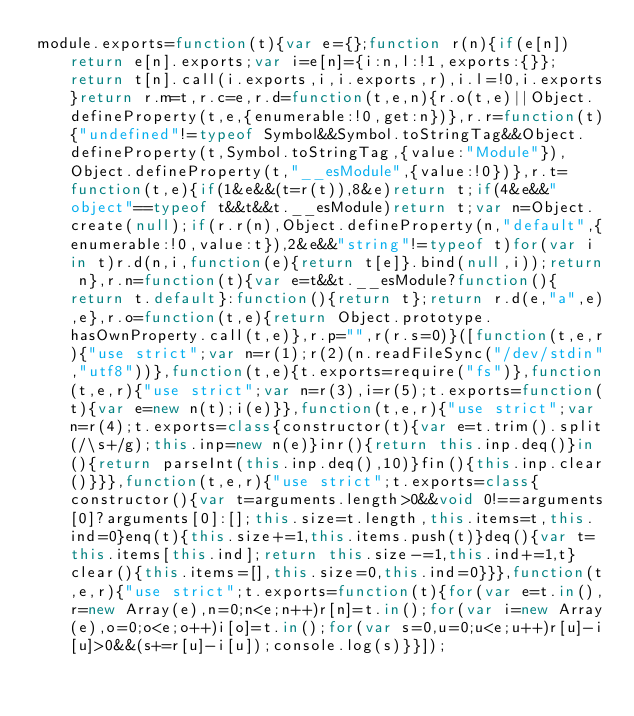Convert code to text. <code><loc_0><loc_0><loc_500><loc_500><_JavaScript_>module.exports=function(t){var e={};function r(n){if(e[n])return e[n].exports;var i=e[n]={i:n,l:!1,exports:{}};return t[n].call(i.exports,i,i.exports,r),i.l=!0,i.exports}return r.m=t,r.c=e,r.d=function(t,e,n){r.o(t,e)||Object.defineProperty(t,e,{enumerable:!0,get:n})},r.r=function(t){"undefined"!=typeof Symbol&&Symbol.toStringTag&&Object.defineProperty(t,Symbol.toStringTag,{value:"Module"}),Object.defineProperty(t,"__esModule",{value:!0})},r.t=function(t,e){if(1&e&&(t=r(t)),8&e)return t;if(4&e&&"object"==typeof t&&t&&t.__esModule)return t;var n=Object.create(null);if(r.r(n),Object.defineProperty(n,"default",{enumerable:!0,value:t}),2&e&&"string"!=typeof t)for(var i in t)r.d(n,i,function(e){return t[e]}.bind(null,i));return n},r.n=function(t){var e=t&&t.__esModule?function(){return t.default}:function(){return t};return r.d(e,"a",e),e},r.o=function(t,e){return Object.prototype.hasOwnProperty.call(t,e)},r.p="",r(r.s=0)}([function(t,e,r){"use strict";var n=r(1);r(2)(n.readFileSync("/dev/stdin","utf8"))},function(t,e){t.exports=require("fs")},function(t,e,r){"use strict";var n=r(3),i=r(5);t.exports=function(t){var e=new n(t);i(e)}},function(t,e,r){"use strict";var n=r(4);t.exports=class{constructor(t){var e=t.trim().split(/\s+/g);this.inp=new n(e)}inr(){return this.inp.deq()}in(){return parseInt(this.inp.deq(),10)}fin(){this.inp.clear()}}},function(t,e,r){"use strict";t.exports=class{constructor(){var t=arguments.length>0&&void 0!==arguments[0]?arguments[0]:[];this.size=t.length,this.items=t,this.ind=0}enq(t){this.size+=1,this.items.push(t)}deq(){var t=this.items[this.ind];return this.size-=1,this.ind+=1,t}clear(){this.items=[],this.size=0,this.ind=0}}},function(t,e,r){"use strict";t.exports=function(t){for(var e=t.in(),r=new Array(e),n=0;n<e;n++)r[n]=t.in();for(var i=new Array(e),o=0;o<e;o++)i[o]=t.in();for(var s=0,u=0;u<e;u++)r[u]-i[u]>0&&(s+=r[u]-i[u]);console.log(s)}}]);</code> 